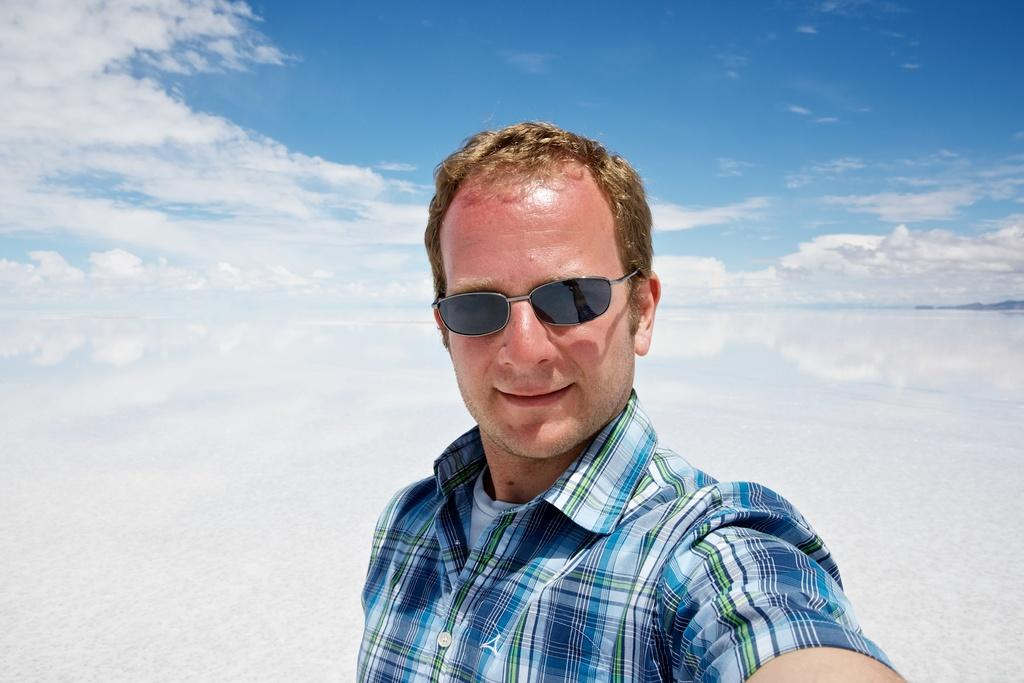Who is present in the image? There is a man in the image. What can be seen in the background of the image? The sky is visible in the background of the image. What is the condition of the sky in the image? Clouds are present in the sky. What type of glass is the mailbox made of in the image? There is no mailbox present in the image, so it is not possible to determine what type of glass it might be made of. 